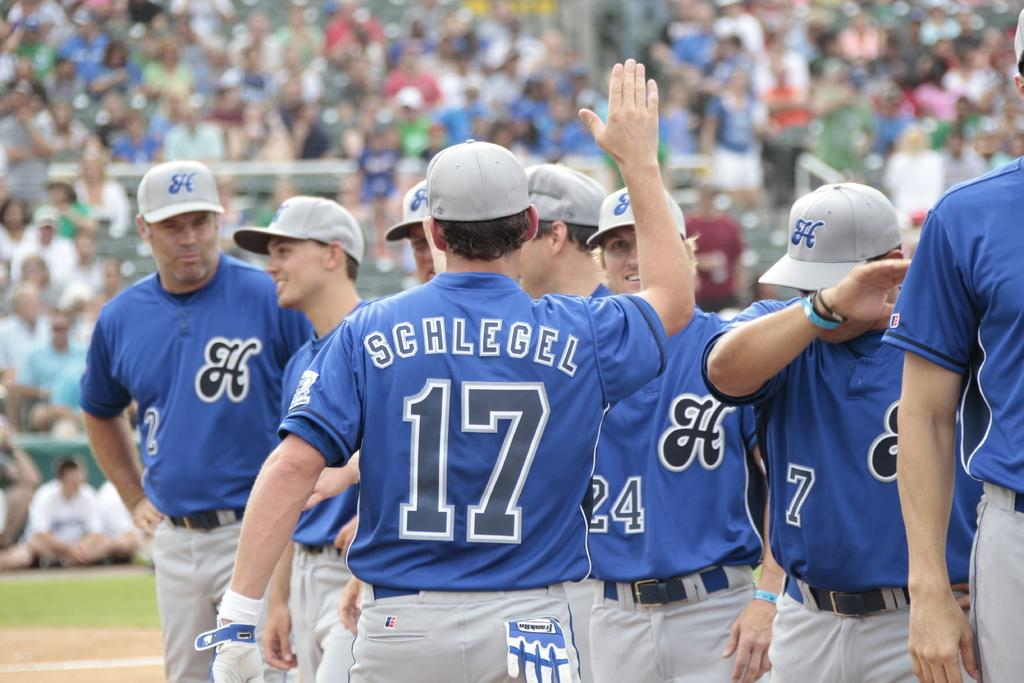<image>
Offer a succinct explanation of the picture presented. The player facing away from the camera is number 17 